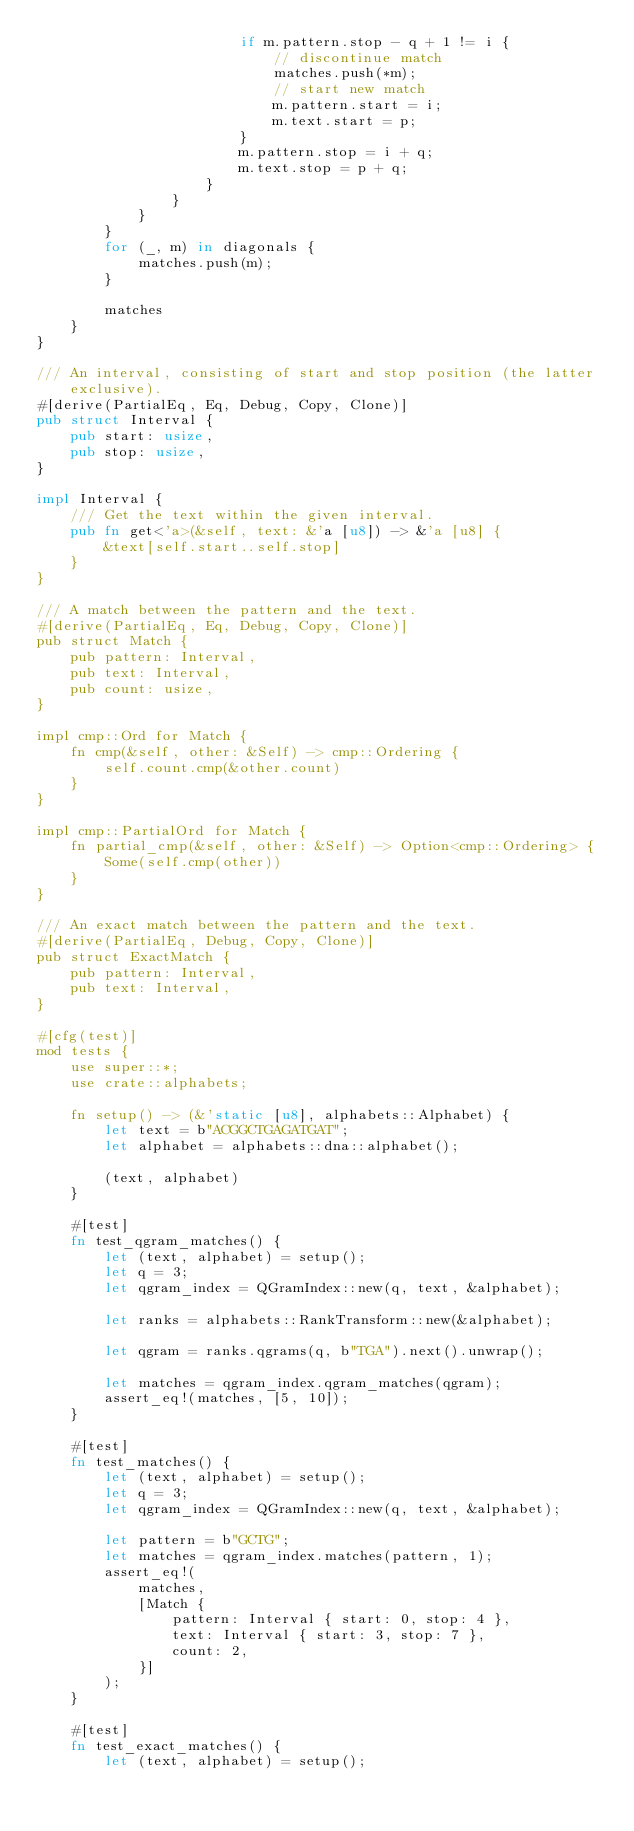Convert code to text. <code><loc_0><loc_0><loc_500><loc_500><_Rust_>                        if m.pattern.stop - q + 1 != i {
                            // discontinue match
                            matches.push(*m);
                            // start new match
                            m.pattern.start = i;
                            m.text.start = p;
                        }
                        m.pattern.stop = i + q;
                        m.text.stop = p + q;
                    }
                }
            }
        }
        for (_, m) in diagonals {
            matches.push(m);
        }

        matches
    }
}

/// An interval, consisting of start and stop position (the latter exclusive).
#[derive(PartialEq, Eq, Debug, Copy, Clone)]
pub struct Interval {
    pub start: usize,
    pub stop: usize,
}

impl Interval {
    /// Get the text within the given interval.
    pub fn get<'a>(&self, text: &'a [u8]) -> &'a [u8] {
        &text[self.start..self.stop]
    }
}

/// A match between the pattern and the text.
#[derive(PartialEq, Eq, Debug, Copy, Clone)]
pub struct Match {
    pub pattern: Interval,
    pub text: Interval,
    pub count: usize,
}

impl cmp::Ord for Match {
    fn cmp(&self, other: &Self) -> cmp::Ordering {
        self.count.cmp(&other.count)
    }
}

impl cmp::PartialOrd for Match {
    fn partial_cmp(&self, other: &Self) -> Option<cmp::Ordering> {
        Some(self.cmp(other))
    }
}

/// An exact match between the pattern and the text.
#[derive(PartialEq, Debug, Copy, Clone)]
pub struct ExactMatch {
    pub pattern: Interval,
    pub text: Interval,
}

#[cfg(test)]
mod tests {
    use super::*;
    use crate::alphabets;

    fn setup() -> (&'static [u8], alphabets::Alphabet) {
        let text = b"ACGGCTGAGATGAT";
        let alphabet = alphabets::dna::alphabet();

        (text, alphabet)
    }

    #[test]
    fn test_qgram_matches() {
        let (text, alphabet) = setup();
        let q = 3;
        let qgram_index = QGramIndex::new(q, text, &alphabet);

        let ranks = alphabets::RankTransform::new(&alphabet);

        let qgram = ranks.qgrams(q, b"TGA").next().unwrap();

        let matches = qgram_index.qgram_matches(qgram);
        assert_eq!(matches, [5, 10]);
    }

    #[test]
    fn test_matches() {
        let (text, alphabet) = setup();
        let q = 3;
        let qgram_index = QGramIndex::new(q, text, &alphabet);

        let pattern = b"GCTG";
        let matches = qgram_index.matches(pattern, 1);
        assert_eq!(
            matches,
            [Match {
                pattern: Interval { start: 0, stop: 4 },
                text: Interval { start: 3, stop: 7 },
                count: 2,
            }]
        );
    }

    #[test]
    fn test_exact_matches() {
        let (text, alphabet) = setup();</code> 